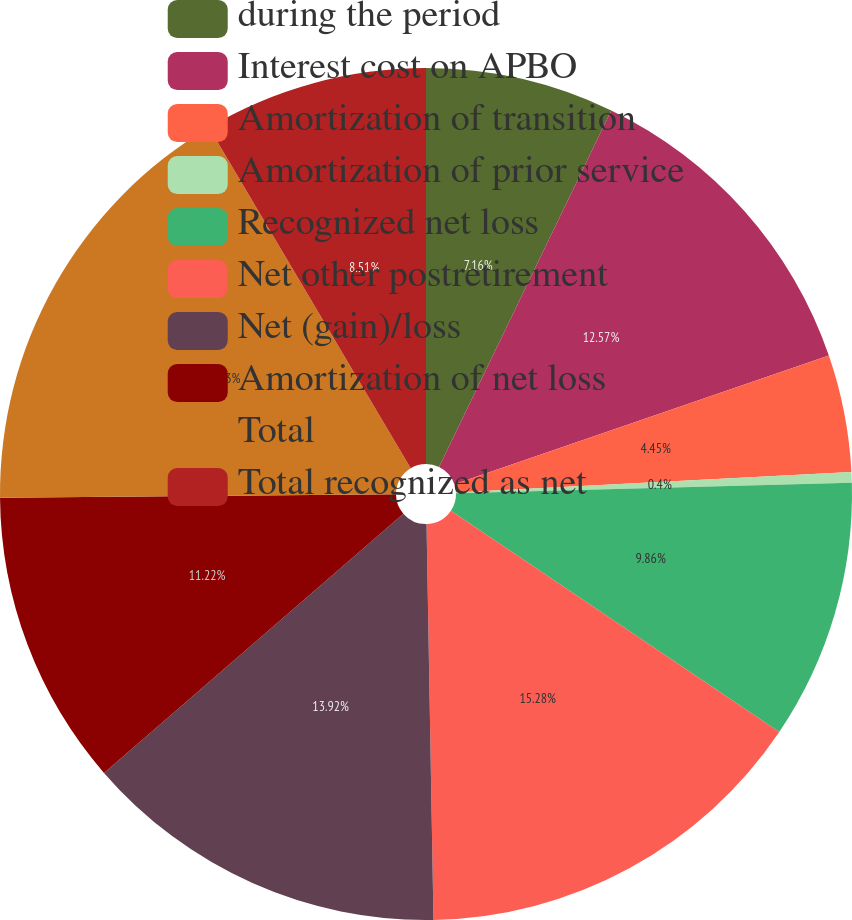Convert chart. <chart><loc_0><loc_0><loc_500><loc_500><pie_chart><fcel>during the period<fcel>Interest cost on APBO<fcel>Amortization of transition<fcel>Amortization of prior service<fcel>Recognized net loss<fcel>Net other postretirement<fcel>Net (gain)/loss<fcel>Amortization of net loss<fcel>Total<fcel>Total recognized as net<nl><fcel>7.16%<fcel>12.57%<fcel>4.45%<fcel>0.4%<fcel>9.86%<fcel>15.28%<fcel>13.92%<fcel>11.22%<fcel>16.63%<fcel>8.51%<nl></chart> 